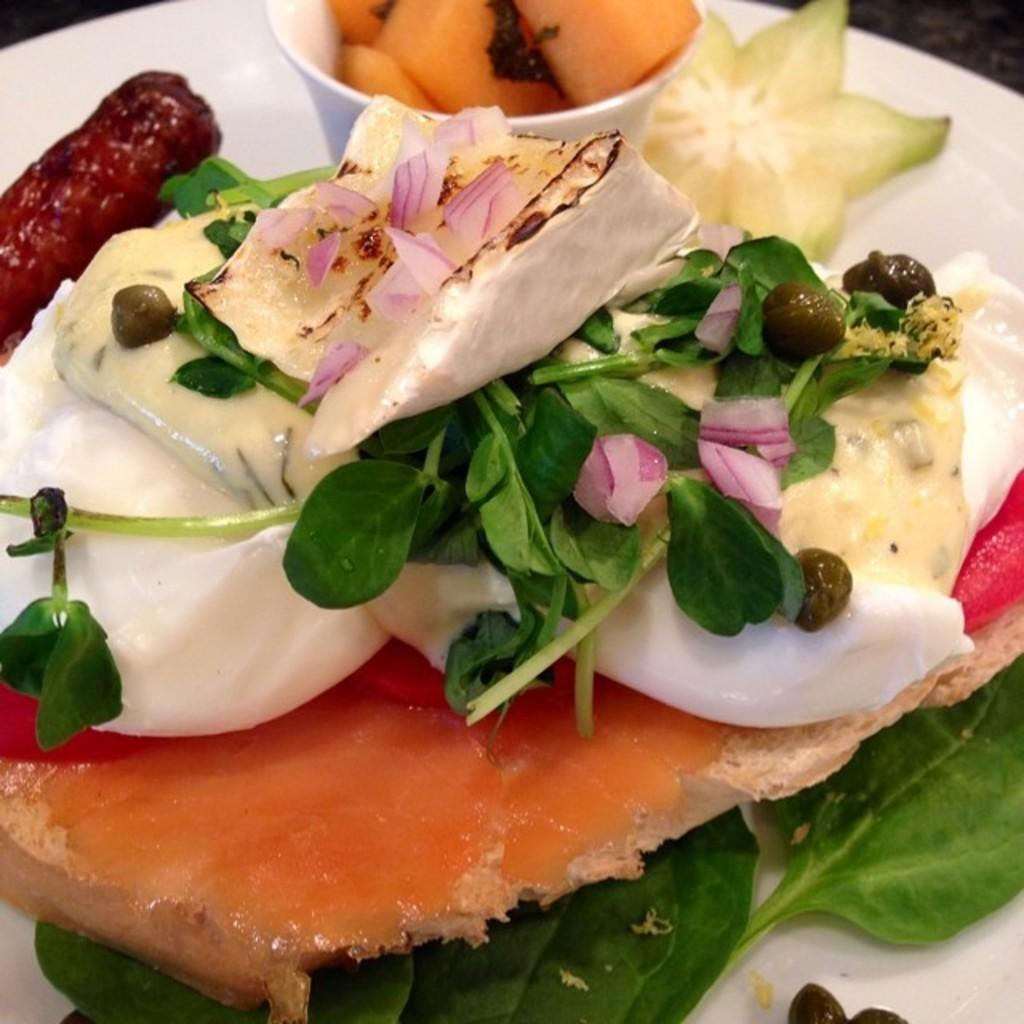What type of food can be seen in the image? There is food in the image, but the specific type cannot be determined from the provided facts. How is the food presented in the image? The food is on a white plate in the image. What specific ingredient is visible in the image? Onions are visible in the image. What type of vegetation is present in the image? There are green leaves visible in the image. How does the food affect the person's throat in the image? There is no person present in the image, so it is impossible to determine how the food might affect their throat. 